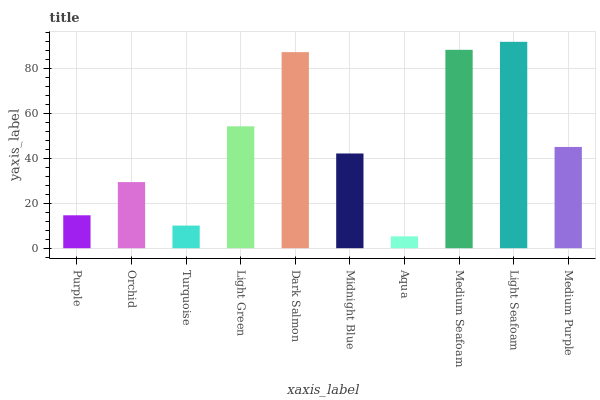Is Aqua the minimum?
Answer yes or no. Yes. Is Light Seafoam the maximum?
Answer yes or no. Yes. Is Orchid the minimum?
Answer yes or no. No. Is Orchid the maximum?
Answer yes or no. No. Is Orchid greater than Purple?
Answer yes or no. Yes. Is Purple less than Orchid?
Answer yes or no. Yes. Is Purple greater than Orchid?
Answer yes or no. No. Is Orchid less than Purple?
Answer yes or no. No. Is Medium Purple the high median?
Answer yes or no. Yes. Is Midnight Blue the low median?
Answer yes or no. Yes. Is Light Green the high median?
Answer yes or no. No. Is Turquoise the low median?
Answer yes or no. No. 